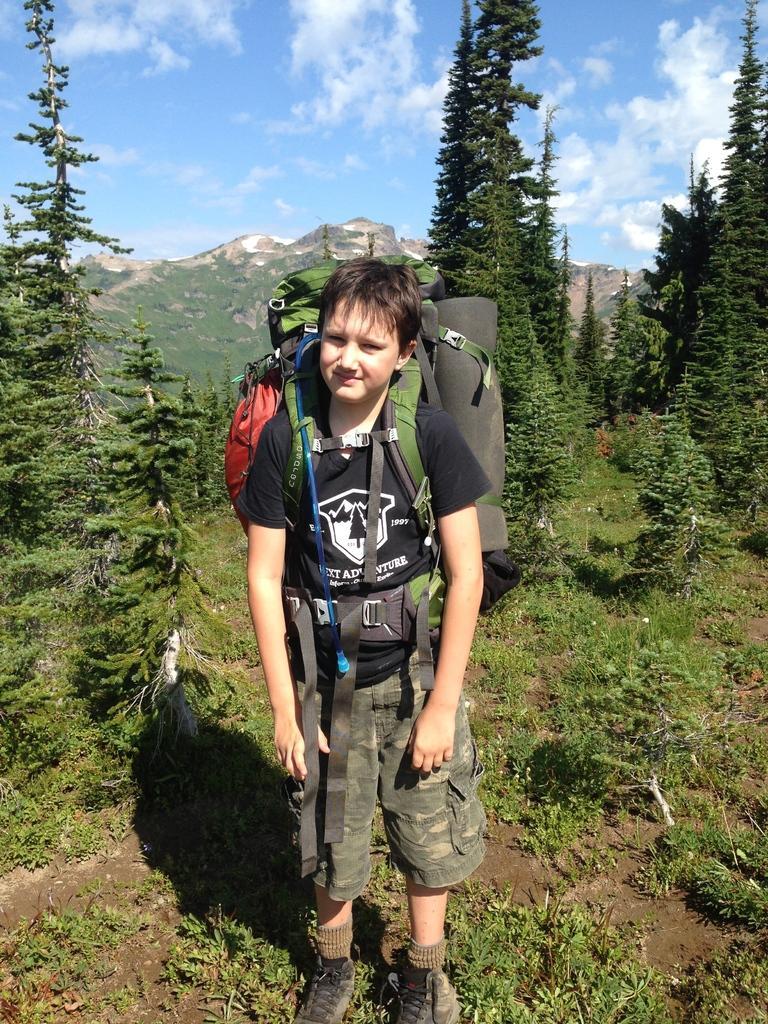How would you summarize this image in a sentence or two? In this image there is a boy who is wearing the bag is standing on the soil. At the back side there are hills and trees. At the top there is sky and clouds. 